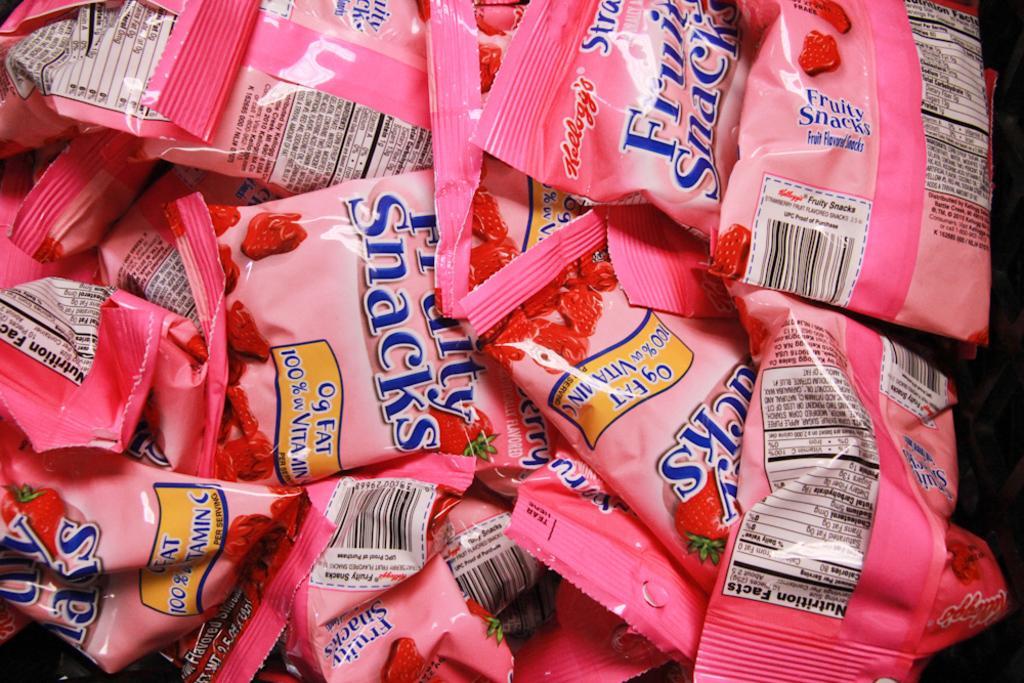Please provide a concise description of this image. In this image I can see a couple of packets with some printed text. 